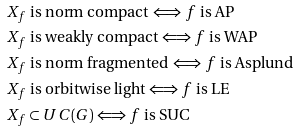<formula> <loc_0><loc_0><loc_500><loc_500>& \text {$X_{f}$ is norm compact $\Longleftrightarrow$ $f$ is AP} \\ & \text {$X_{f}$ is weakly compact $\Longleftrightarrow$ $f$ is WAP} \\ & \text {$X_{f}$ is norm fragmented $\Longleftrightarrow$ $f$ is Asplund $\quad$ } \\ & \text {$X_{f}$ is orbitwise light $\Longleftrightarrow$ $f$ is LE $\quad$} \\ & \text {$X_{f} \subset UC(G)$ $\Longleftrightarrow$ $f$ is SUC $\quad$} \\</formula> 